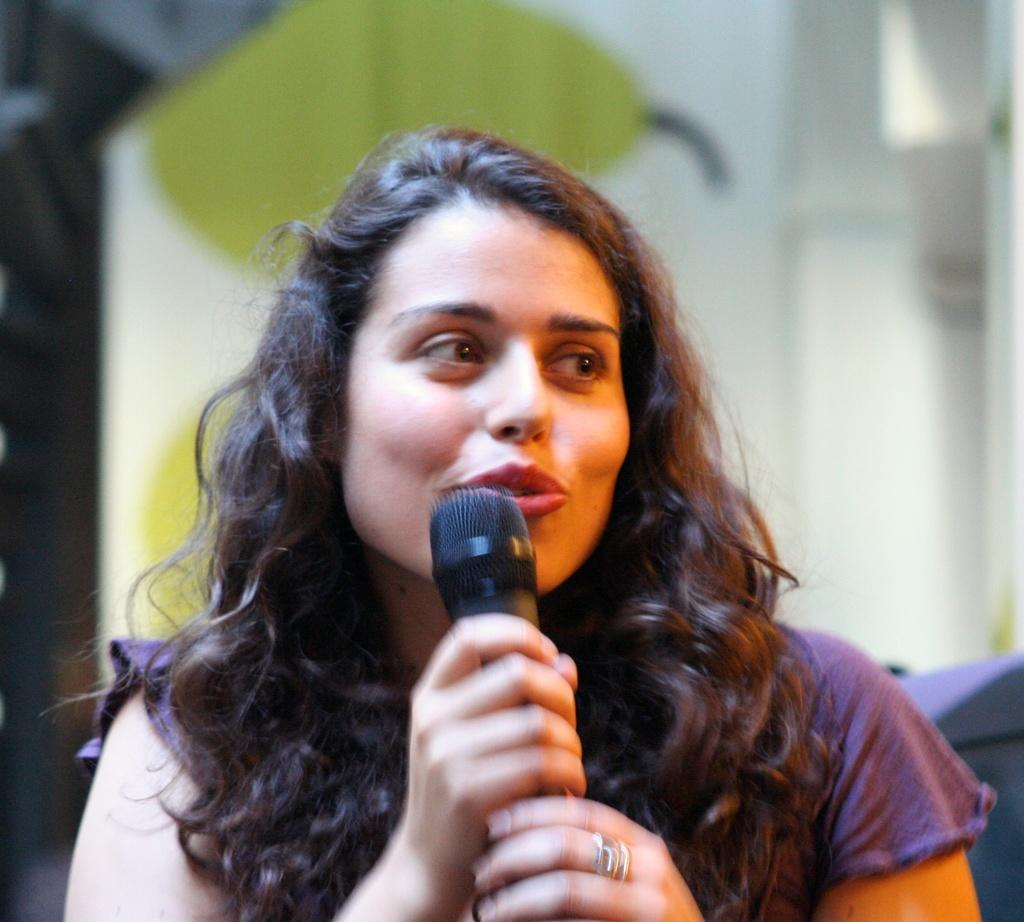What is the main subject of the image? The main subject of the image is a woman. What is the woman doing in the image? The woman is speaking in the image. What object is the woman holding in her hand? The woman is holding a microphone in her hand. What type of noise can be heard coming from the woman in the image? There is no indication in the image that any noise is being made, so it's not possible to determine what type of noise might be heard. 